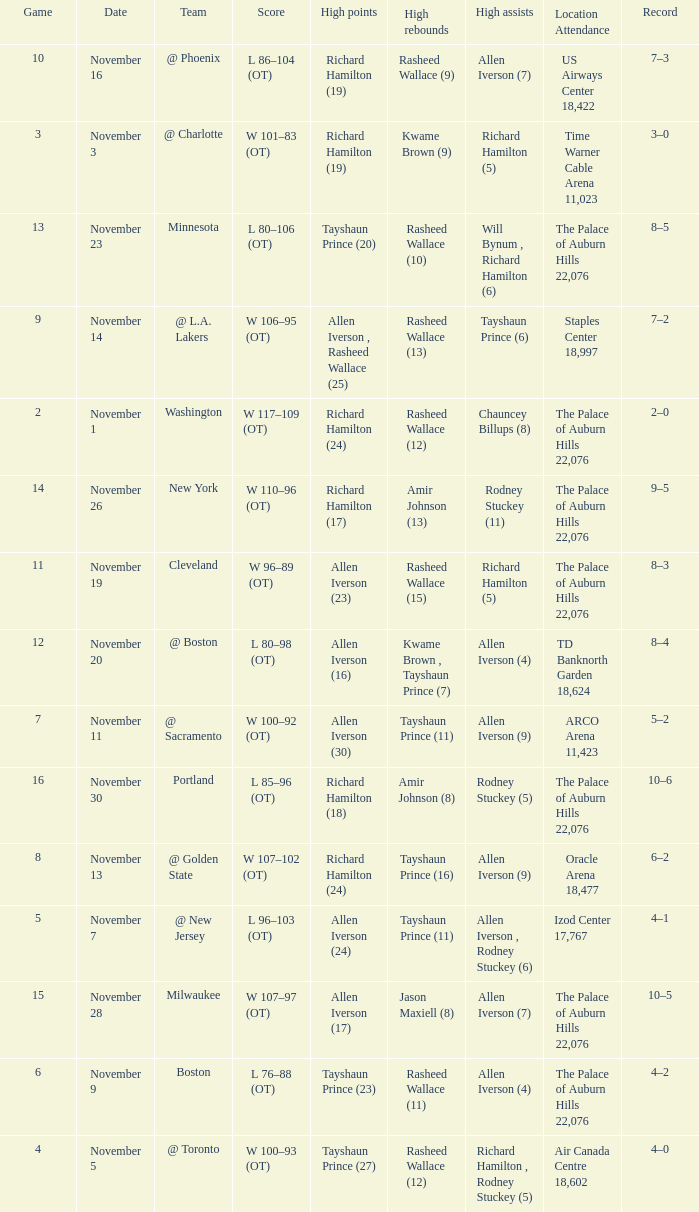What is High Points, when Game is less than 10, and when High Assists is "Chauncey Billups (8)"? Richard Hamilton (24). 